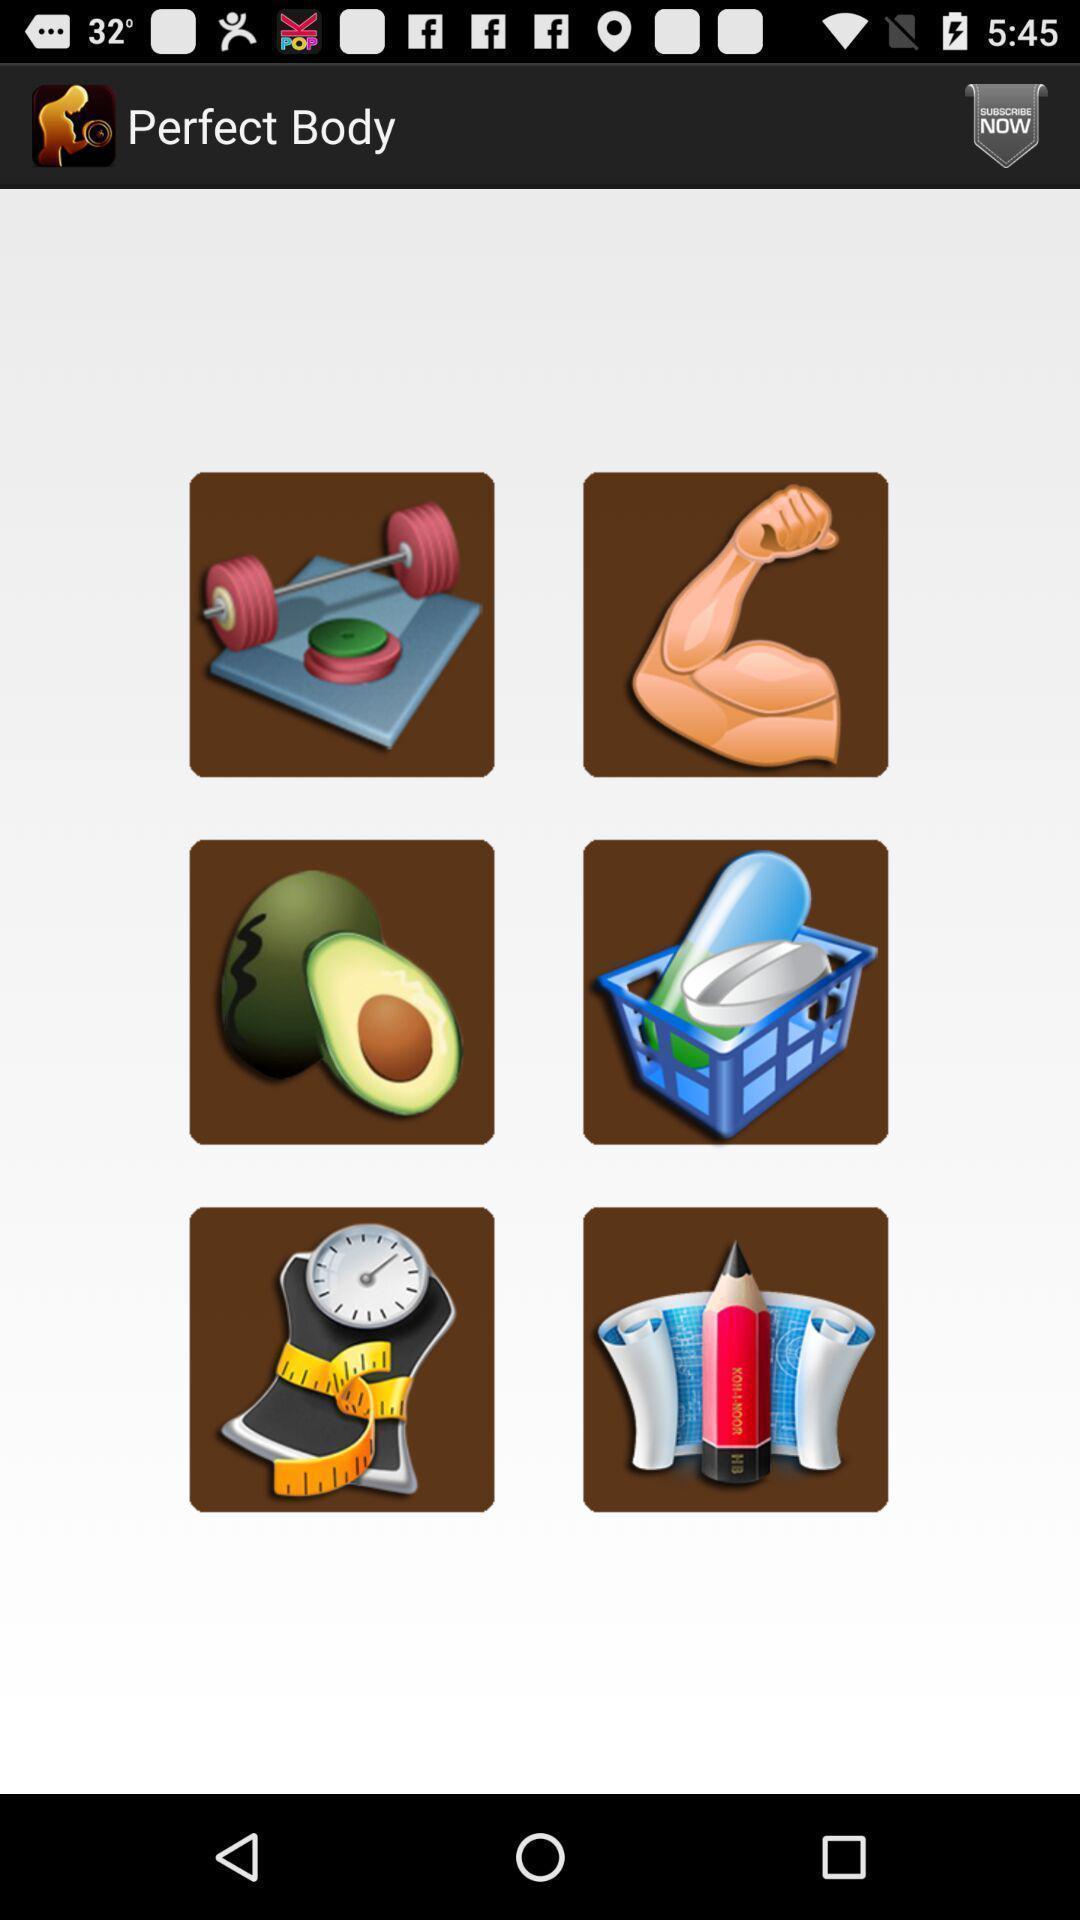Provide a textual representation of this image. Screen displaying a list of images. 